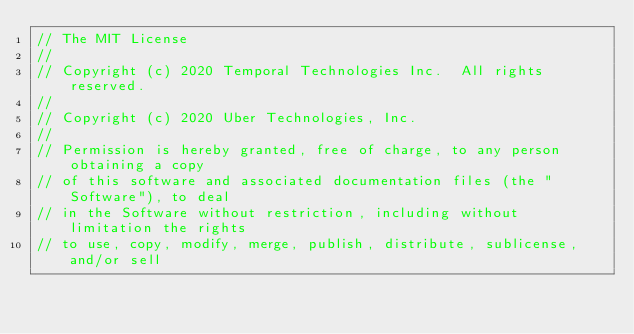Convert code to text. <code><loc_0><loc_0><loc_500><loc_500><_Go_>// The MIT License
//
// Copyright (c) 2020 Temporal Technologies Inc.  All rights reserved.
//
// Copyright (c) 2020 Uber Technologies, Inc.
//
// Permission is hereby granted, free of charge, to any person obtaining a copy
// of this software and associated documentation files (the "Software"), to deal
// in the Software without restriction, including without limitation the rights
// to use, copy, modify, merge, publish, distribute, sublicense, and/or sell</code> 